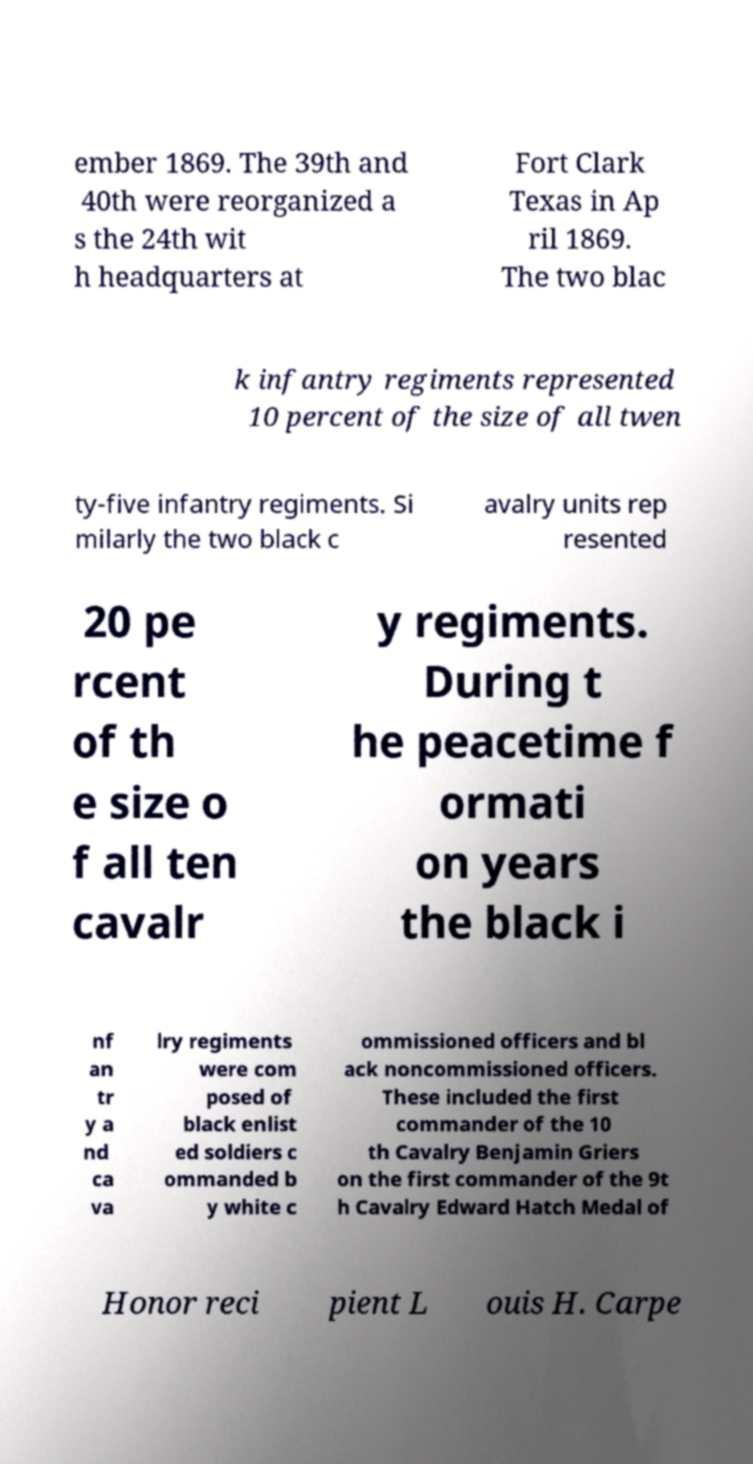What messages or text are displayed in this image? I need them in a readable, typed format. ember 1869. The 39th and 40th were reorganized a s the 24th wit h headquarters at Fort Clark Texas in Ap ril 1869. The two blac k infantry regiments represented 10 percent of the size of all twen ty-five infantry regiments. Si milarly the two black c avalry units rep resented 20 pe rcent of th e size o f all ten cavalr y regiments. During t he peacetime f ormati on years the black i nf an tr y a nd ca va lry regiments were com posed of black enlist ed soldiers c ommanded b y white c ommissioned officers and bl ack noncommissioned officers. These included the first commander of the 10 th Cavalry Benjamin Griers on the first commander of the 9t h Cavalry Edward Hatch Medal of Honor reci pient L ouis H. Carpe 